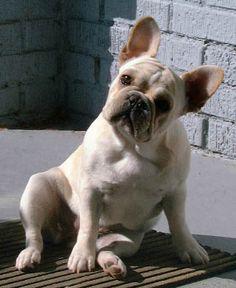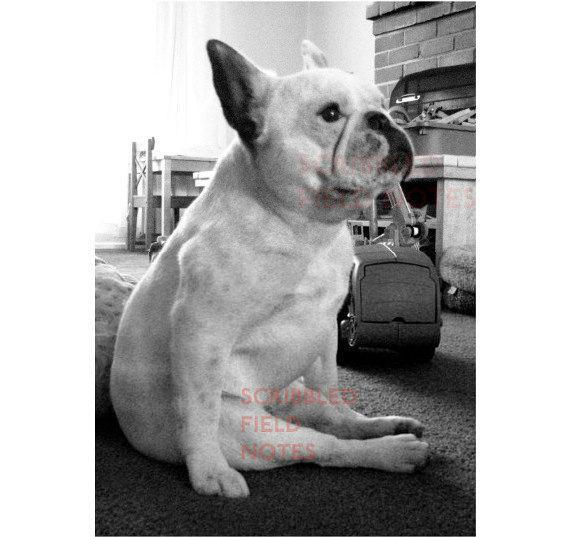The first image is the image on the left, the second image is the image on the right. Analyze the images presented: Is the assertion "An image shows a whitish dog sitting with hind legs sticking forward on a carpet indoors." valid? Answer yes or no. Yes. The first image is the image on the left, the second image is the image on the right. For the images shown, is this caption "One dog is indoors, and another is outdoors." true? Answer yes or no. Yes. 